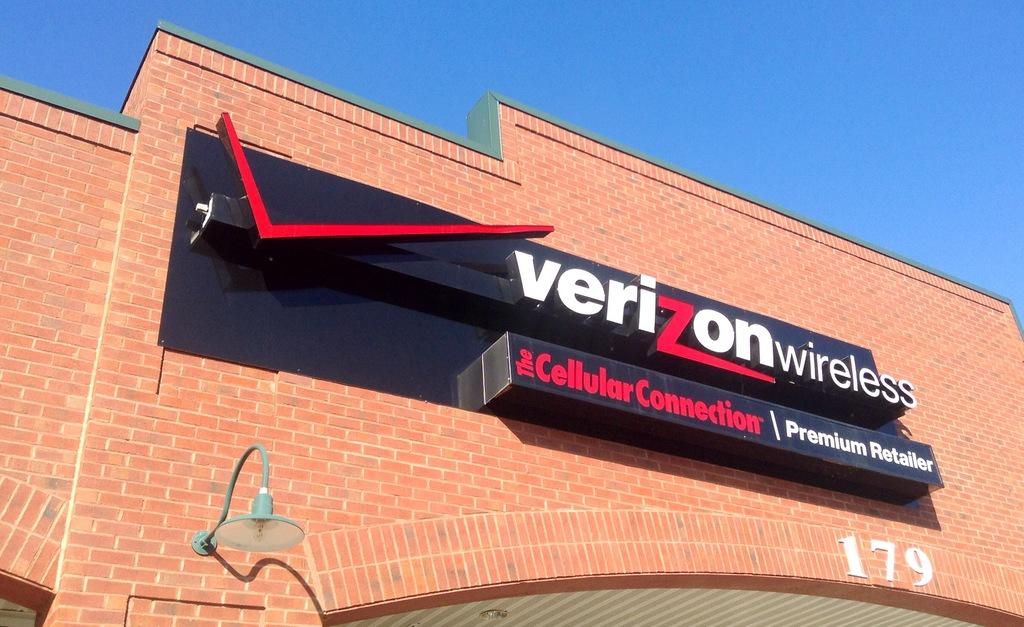Provide a one-sentence caption for the provided image. A brick building has a Verizon wireless sign on it. 